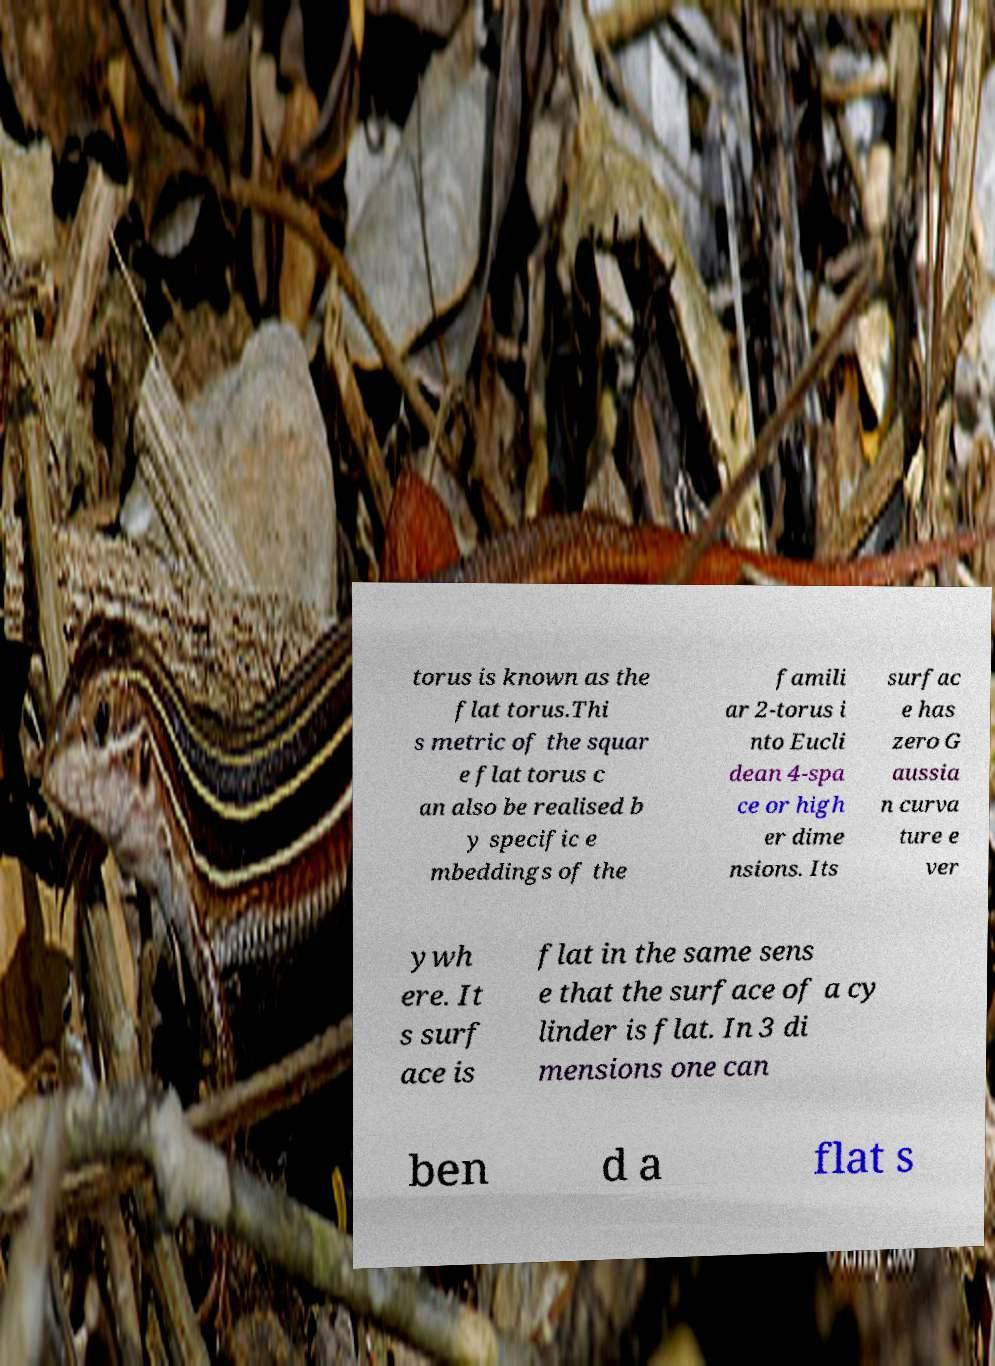Please identify and transcribe the text found in this image. torus is known as the flat torus.Thi s metric of the squar e flat torus c an also be realised b y specific e mbeddings of the famili ar 2-torus i nto Eucli dean 4-spa ce or high er dime nsions. Its surfac e has zero G aussia n curva ture e ver ywh ere. It s surf ace is flat in the same sens e that the surface of a cy linder is flat. In 3 di mensions one can ben d a flat s 